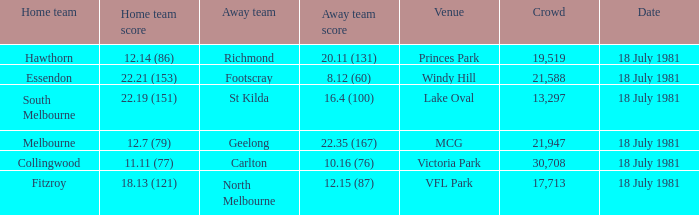On which date was the essendon home game? 18 July 1981. 